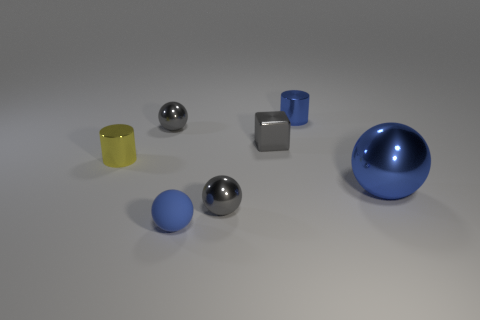Subtract all large spheres. How many spheres are left? 3 Subtract all green cubes. How many blue balls are left? 2 Add 1 balls. How many objects exist? 8 Add 2 metal spheres. How many metal spheres exist? 5 Subtract 0 red blocks. How many objects are left? 7 Subtract all spheres. How many objects are left? 3 Subtract all green spheres. Subtract all cyan cylinders. How many spheres are left? 4 Subtract all cubes. Subtract all gray shiny things. How many objects are left? 3 Add 5 blue balls. How many blue balls are left? 7 